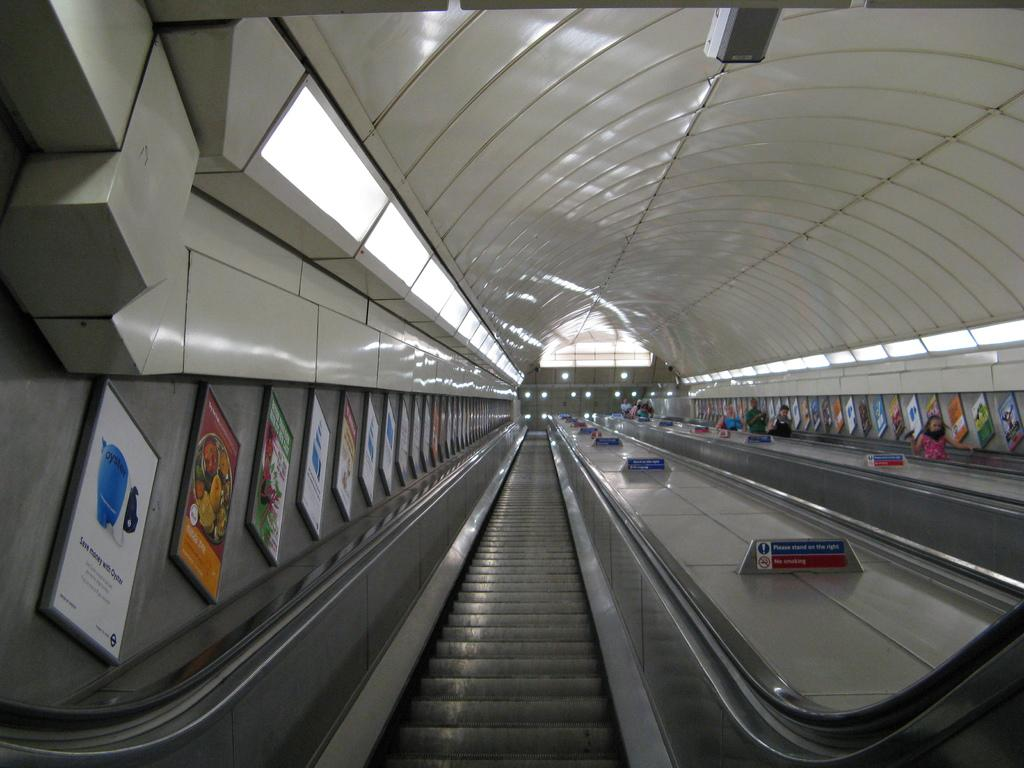What type of transportation device is present in the image? There is an escalator in the image. What can be seen on the wall in the image? There are boards on the wall in the image. Where are the people located in the image? The people are on the right side of the image. What type of heat source can be seen in the image? There is no heat source present in the image. Can you describe how the people are flying in the image? The people are not flying in the image; they are standing or walking on the right side. 